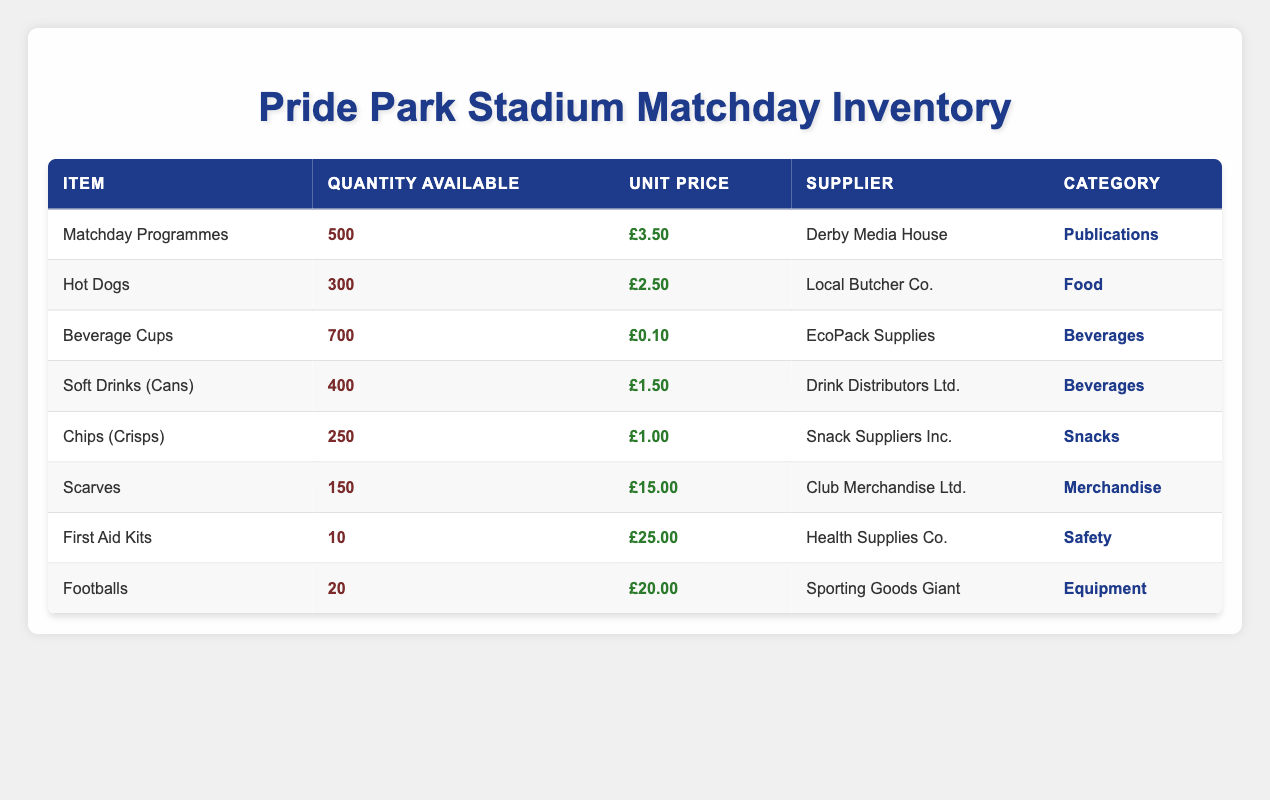What is the quantity available for Matchday Programmes? The table lists the quantity available for Matchday Programmes as 500.
Answer: 500 What is the unit price of Hot Dogs? The unit price for Hot Dogs is found in the table, which states it is £2.50.
Answer: £2.50 How many beverage cups are available? The table shows that there are 700 Beverage Cups available.
Answer: 700 Is the supplier for Soft Drinks the same as for Chips? The supplier for Soft Drinks is Drink Distributors Ltd., while the supplier for Chips is Snack Suppliers Inc., so they are not the same.
Answer: No What is the total number of food items (Hot Dogs and Chips) available? The quantity of Hot Dogs is 300, and the quantity of Chips is 250. Adding these together gives 300 + 250 = 550.
Answer: 550 Which item has the highest unit price? By examining the table, the unit price of Scarves is £15.00, which is higher than any other item.
Answer: Scarves How many more soft drinks are available than hot dogs? Soft Drinks (Cans) have a quantity of 400, while Hot Dogs have 300. The difference is 400 - 300 = 100.
Answer: 100 What is the average unit price of all food items available? The food items are Hot Dogs (£2.50) and Chips (£1.00). Their total price is £2.50 + £1.00 = £3.50. There are 2 food items, so the average is £3.50 / 2 = £1.75.
Answer: £1.75 Are there more scarves or first aid kits available? The table shows 150 Scarves and 10 First Aid Kits. Since 150 is greater than 10, the answer is yes.
Answer: Yes 